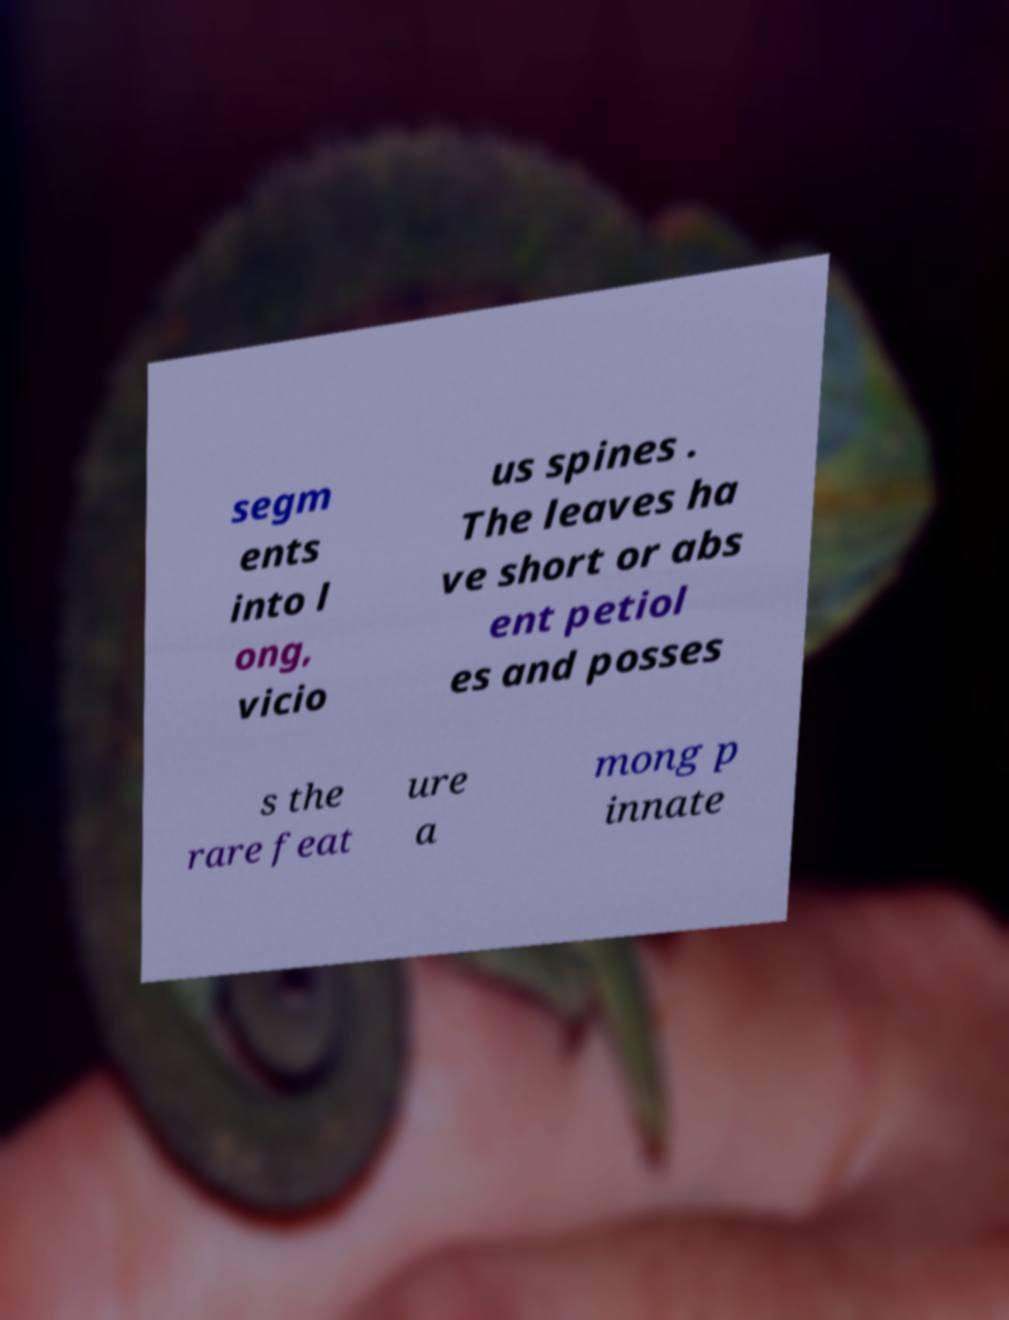Can you read and provide the text displayed in the image?This photo seems to have some interesting text. Can you extract and type it out for me? segm ents into l ong, vicio us spines . The leaves ha ve short or abs ent petiol es and posses s the rare feat ure a mong p innate 